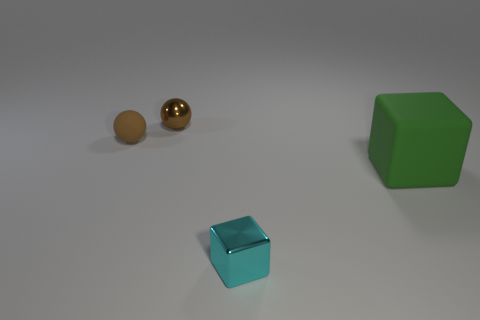Add 4 big blue cylinders. How many objects exist? 8 Add 2 green cubes. How many green cubes exist? 3 Subtract 0 cyan cylinders. How many objects are left? 4 Subtract all cyan blocks. Subtract all small blue shiny cubes. How many objects are left? 3 Add 1 large green rubber objects. How many large green rubber objects are left? 2 